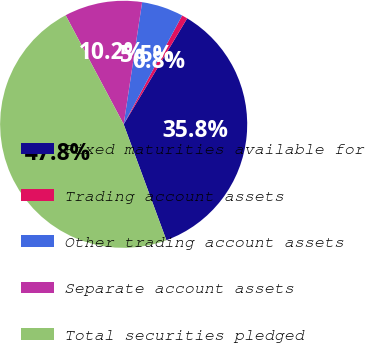Convert chart. <chart><loc_0><loc_0><loc_500><loc_500><pie_chart><fcel>Fixed maturities available for<fcel>Trading account assets<fcel>Other trading account assets<fcel>Separate account assets<fcel>Total securities pledged<nl><fcel>35.78%<fcel>0.75%<fcel>5.46%<fcel>10.17%<fcel>47.84%<nl></chart> 